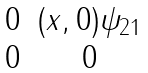<formula> <loc_0><loc_0><loc_500><loc_500>\begin{matrix} 0 & ( x , 0 ) \psi _ { 2 1 } \\ 0 & 0 \end{matrix}</formula> 